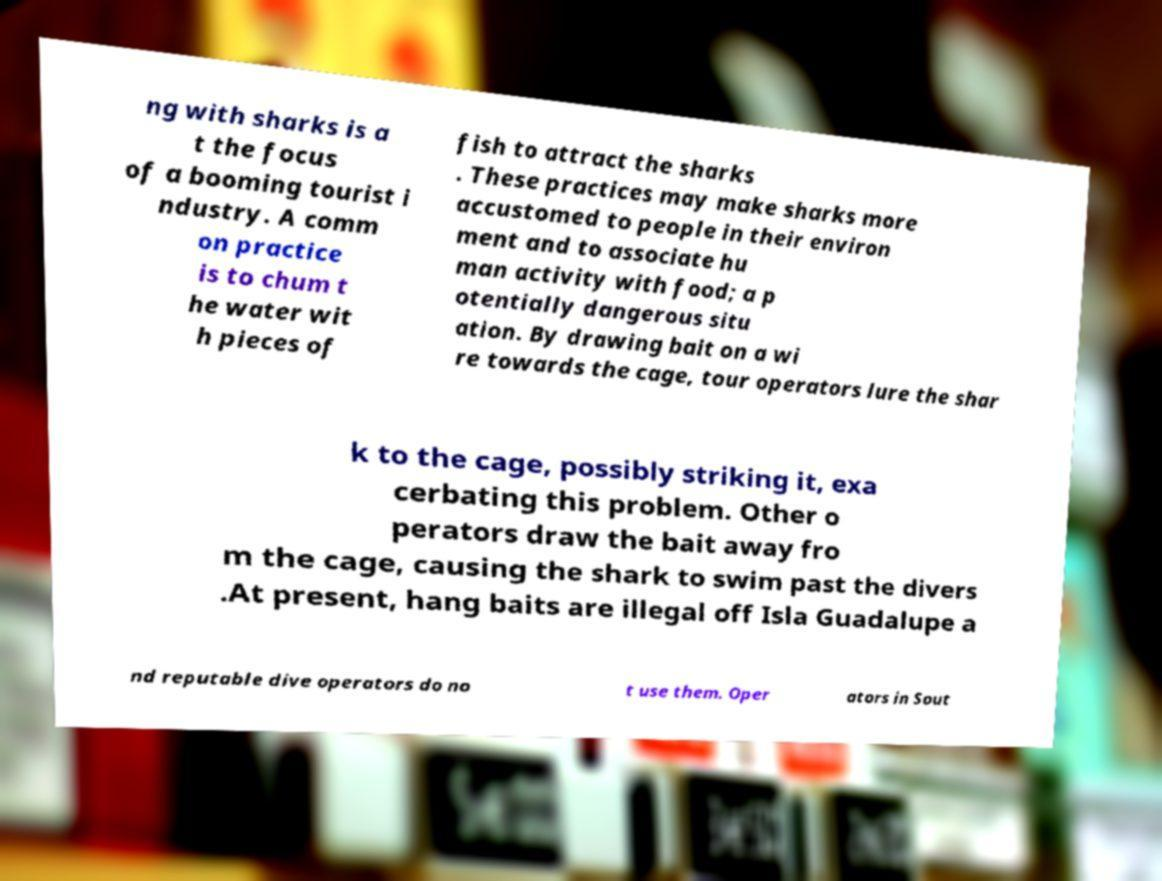Could you extract and type out the text from this image? ng with sharks is a t the focus of a booming tourist i ndustry. A comm on practice is to chum t he water wit h pieces of fish to attract the sharks . These practices may make sharks more accustomed to people in their environ ment and to associate hu man activity with food; a p otentially dangerous situ ation. By drawing bait on a wi re towards the cage, tour operators lure the shar k to the cage, possibly striking it, exa cerbating this problem. Other o perators draw the bait away fro m the cage, causing the shark to swim past the divers .At present, hang baits are illegal off Isla Guadalupe a nd reputable dive operators do no t use them. Oper ators in Sout 